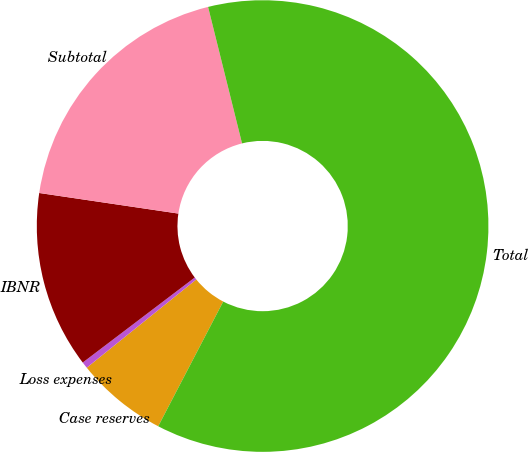Convert chart. <chart><loc_0><loc_0><loc_500><loc_500><pie_chart><fcel>Case reserves<fcel>Loss expenses<fcel>IBNR<fcel>Subtotal<fcel>Total<nl><fcel>6.56%<fcel>0.46%<fcel>12.67%<fcel>18.78%<fcel>61.53%<nl></chart> 